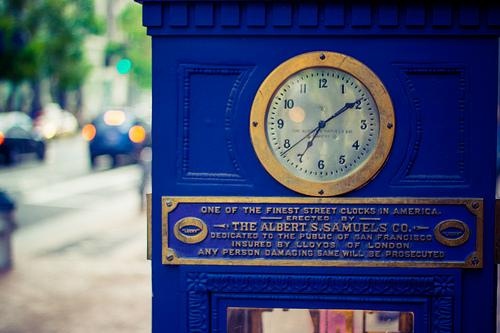Question: where is this clock?
Choices:
A. On a tower.
B. On a nightstand.
C. San Francisco.
D. In a cell phone.
Answer with the letter. Answer: C Question: who insures this clock?
Choices:
A. Lloyds of London.
B. Nobody.
C. The local government.
D. The owner.
Answer with the letter. Answer: A Question: who is the maker of this clock?
Choices:
A. The fifth grade class.
B. The monks.
C. The Albert S. Samuels company.
D. Robots.
Answer with the letter. Answer: C Question: who is this clock dedicated to?
Choices:
A. Fallen soldiers.
B. Those who died of scurvy.
C. Mothers everywhere.
D. The public of San Francisco.
Answer with the letter. Answer: D Question: what color is the box the clock is mounted on?
Choices:
A. Blue.
B. Red.
C. Black.
D. Green.
Answer with the letter. Answer: A Question: what time is it?
Choices:
A. 7:19.
B. 7:09.
C. 8:09.
D. Lunchtime.
Answer with the letter. Answer: B Question: what is below the clock?
Choices:
A. Pigeons.
B. Mirror.
C. Gargoyles.
D. Scaffolding.
Answer with the letter. Answer: B 